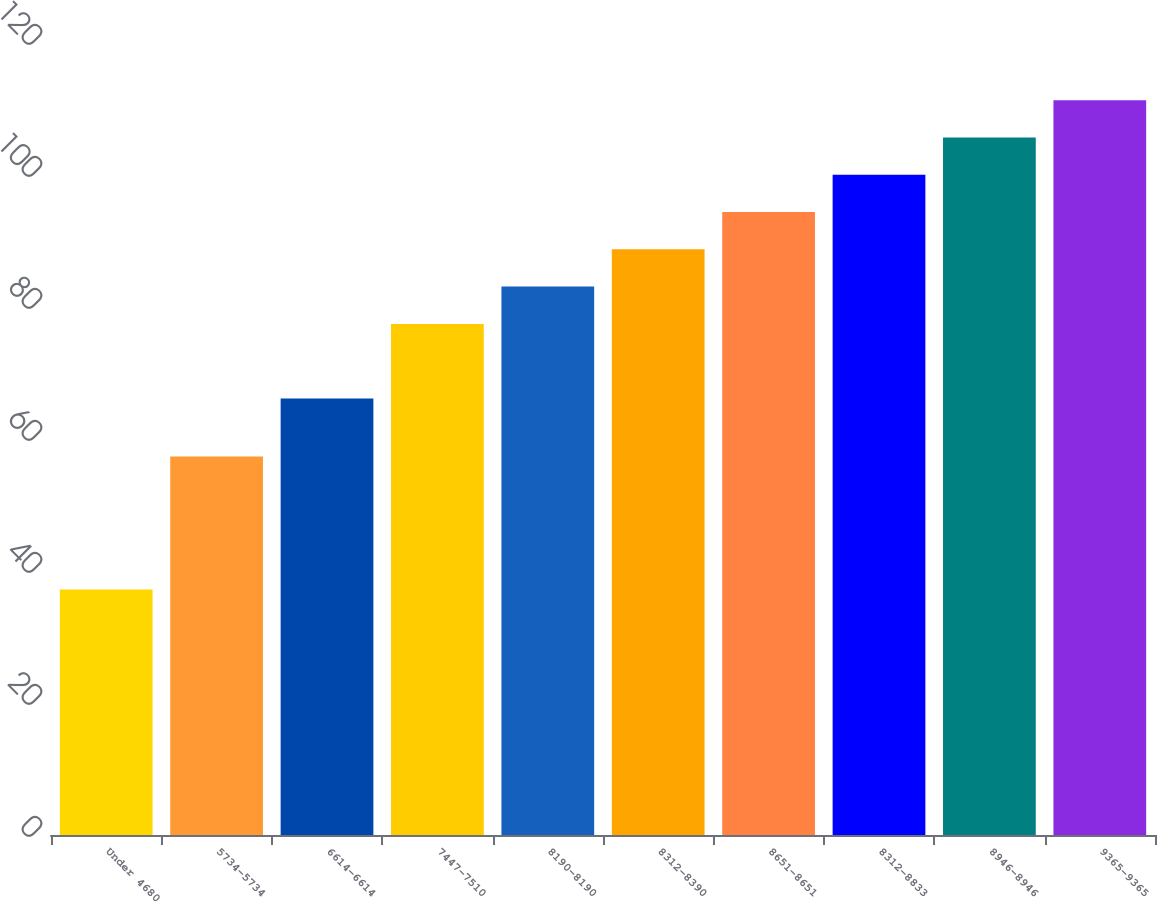Convert chart. <chart><loc_0><loc_0><loc_500><loc_500><bar_chart><fcel>Under 4680<fcel>5734-5734<fcel>6614-6614<fcel>7447-7510<fcel>8190-8190<fcel>8312-8390<fcel>8651-8651<fcel>8312-8833<fcel>8946-8946<fcel>9365-9365<nl><fcel>37.18<fcel>57.34<fcel>66.14<fcel>77.44<fcel>83.09<fcel>88.74<fcel>94.39<fcel>100.04<fcel>105.69<fcel>111.34<nl></chart> 